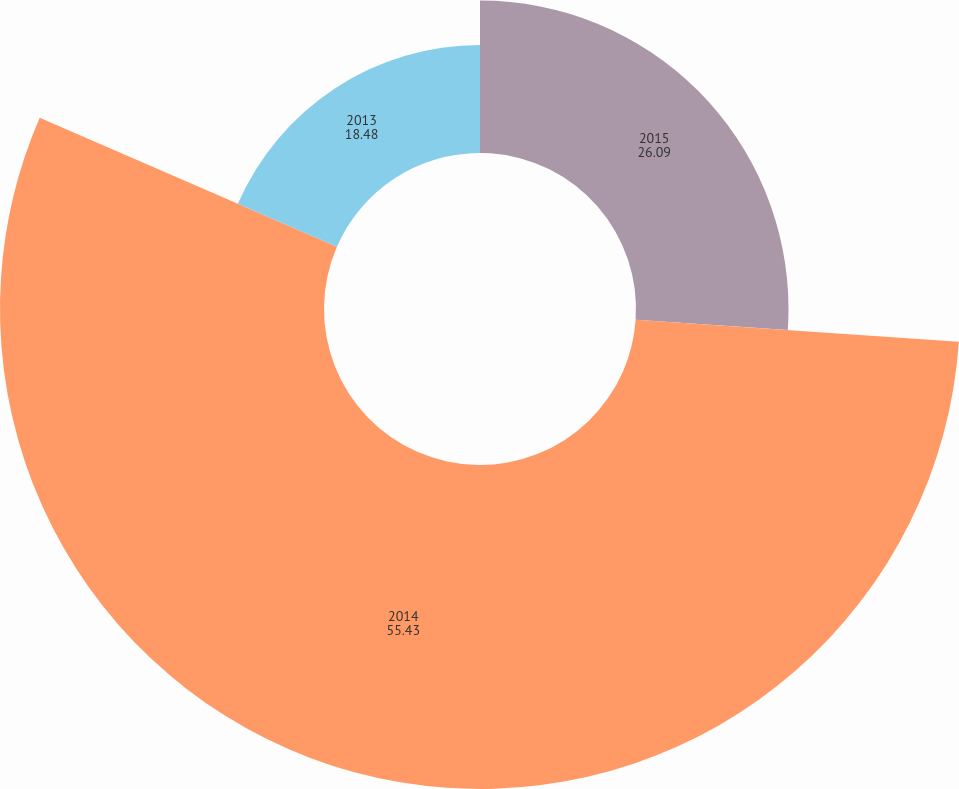Convert chart. <chart><loc_0><loc_0><loc_500><loc_500><pie_chart><fcel>2015<fcel>2014<fcel>2013<nl><fcel>26.09%<fcel>55.43%<fcel>18.48%<nl></chart> 